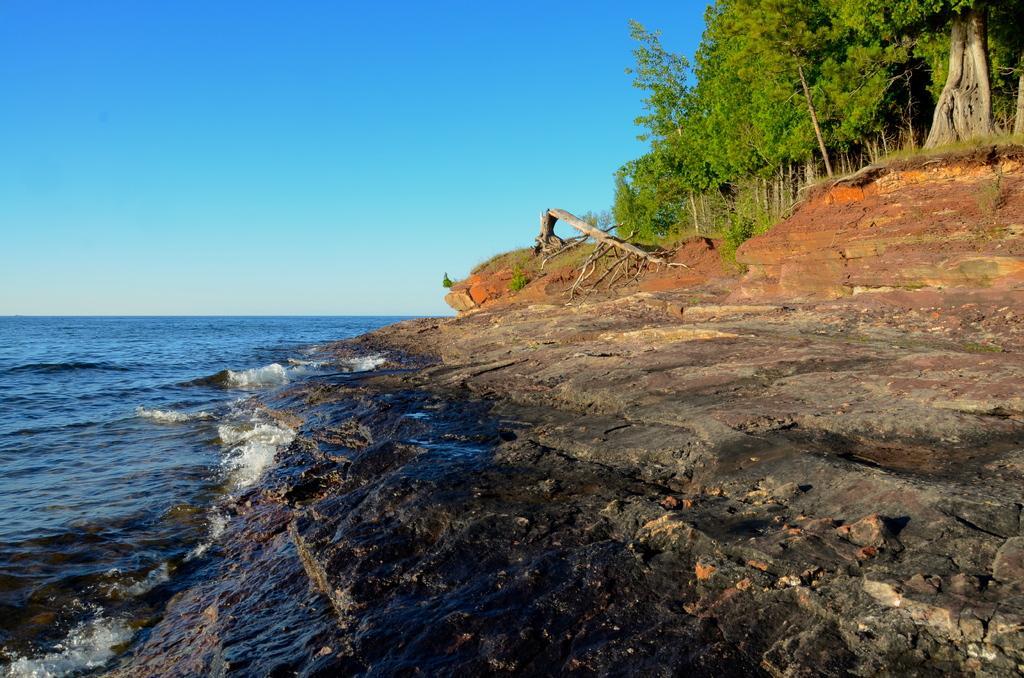Could you give a brief overview of what you see in this image? Here on the left side we can see water and on the right side we can see rock and trees on the ground and this is a sky. 